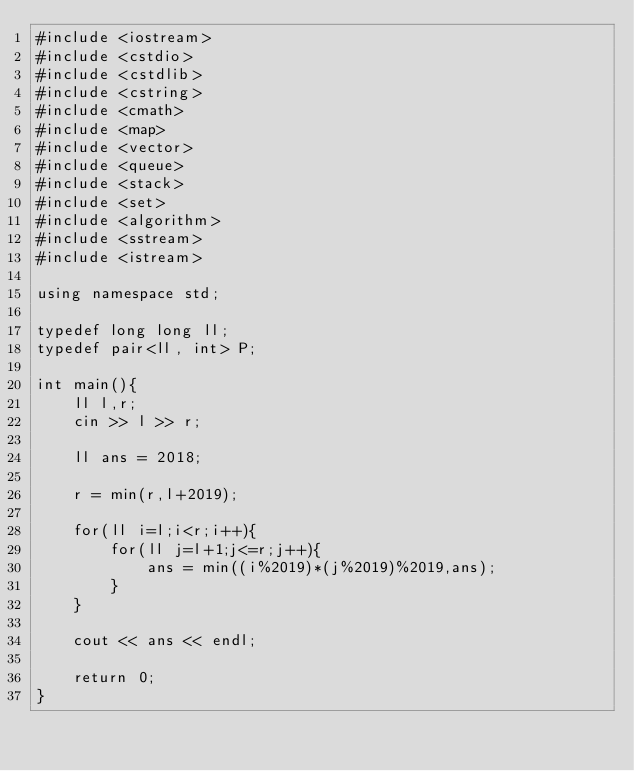<code> <loc_0><loc_0><loc_500><loc_500><_C++_>#include <iostream>
#include <cstdio>
#include <cstdlib>
#include <cstring>
#include <cmath>
#include <map>
#include <vector>
#include <queue>
#include <stack>
#include <set>
#include <algorithm>
#include <sstream>
#include <istream>

using namespace std;

typedef long long ll;
typedef pair<ll, int> P;

int main(){
	ll l,r;
	cin >> l >> r;

	ll ans = 2018;

	r = min(r,l+2019);

	for(ll i=l;i<r;i++){
		for(ll j=l+1;j<=r;j++){
			ans = min((i%2019)*(j%2019)%2019,ans);
		}
	}

	cout << ans << endl;

	return 0;
}</code> 